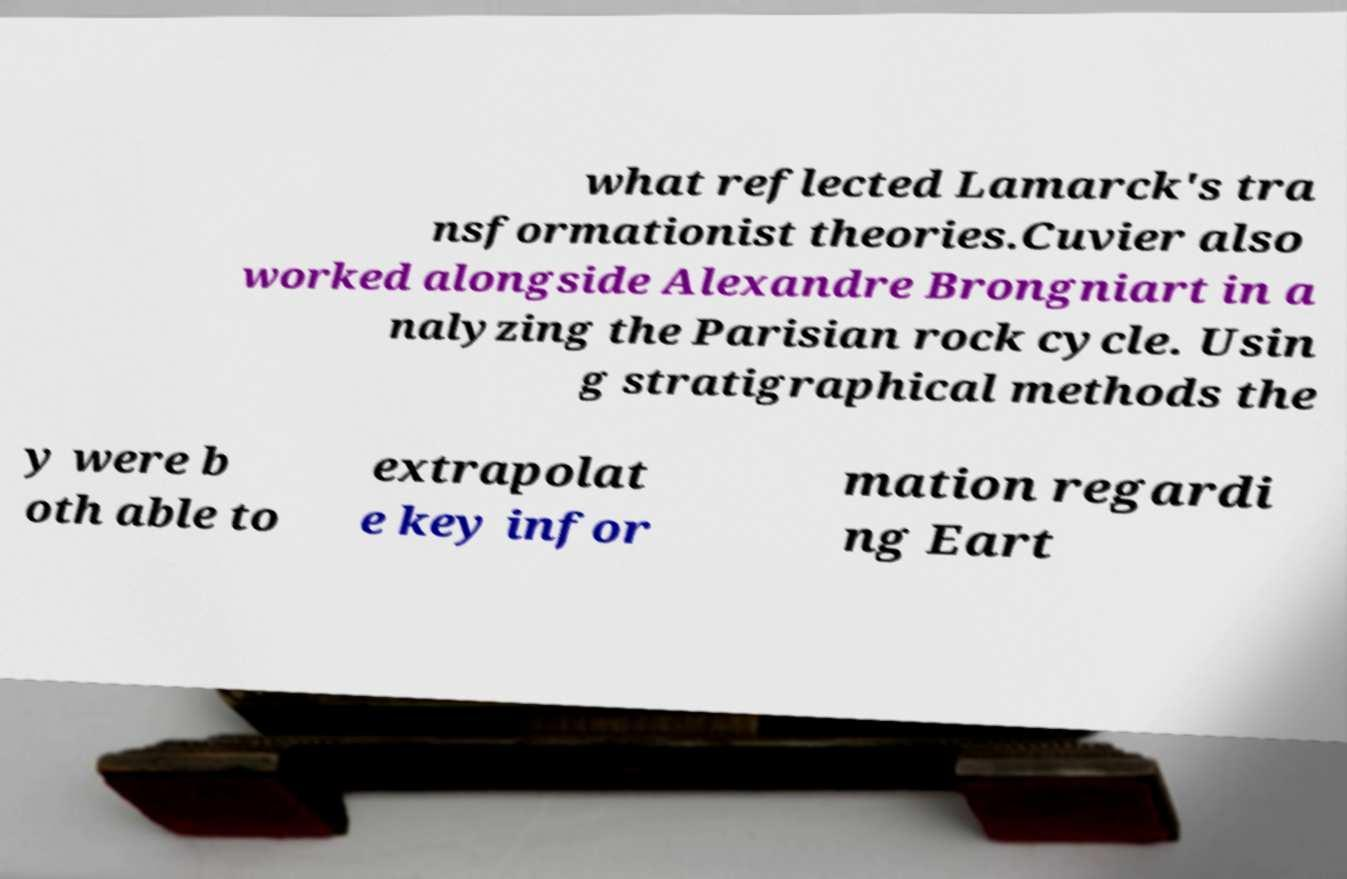Can you read and provide the text displayed in the image?This photo seems to have some interesting text. Can you extract and type it out for me? what reflected Lamarck's tra nsformationist theories.Cuvier also worked alongside Alexandre Brongniart in a nalyzing the Parisian rock cycle. Usin g stratigraphical methods the y were b oth able to extrapolat e key infor mation regardi ng Eart 